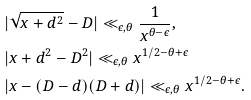<formula> <loc_0><loc_0><loc_500><loc_500>& | \sqrt { x + d ^ { 2 } } - D | \ll _ { \epsilon , \theta } \frac { 1 } { x ^ { \theta - \epsilon } } , \\ & | x + d ^ { 2 } - D ^ { 2 } | \ll _ { \epsilon , \theta } x ^ { 1 / 2 - \theta + \epsilon } \\ & | x - ( D - d ) ( D + d ) | \ll _ { \epsilon , \theta } x ^ { 1 / 2 - \theta + \epsilon } .</formula> 